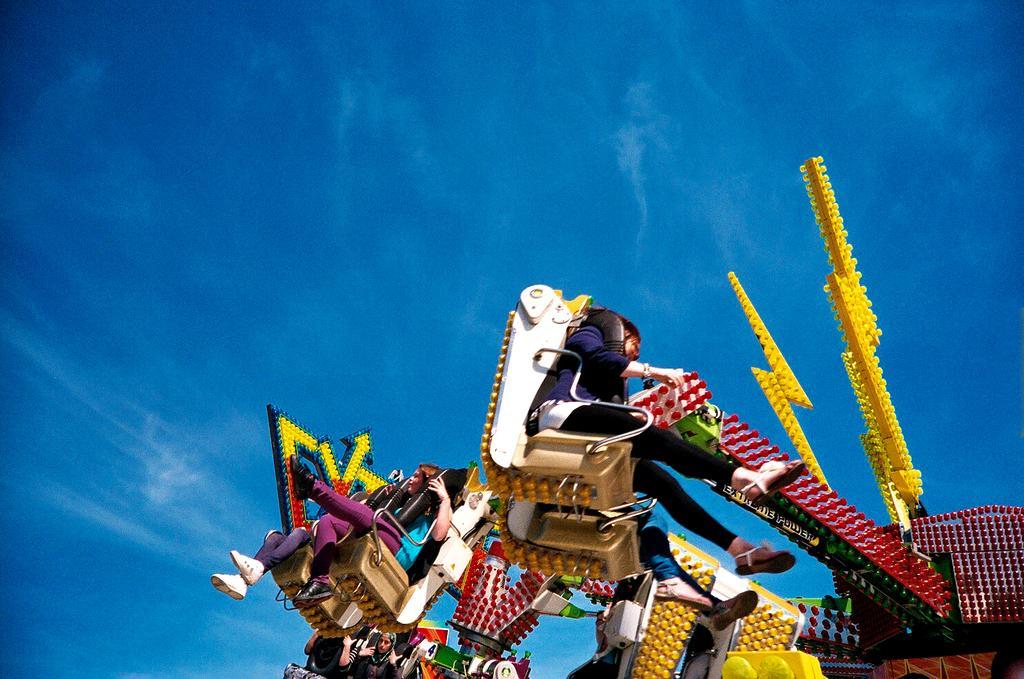In one or two sentences, can you explain what this image depicts? This is an outside view. Here I can see a few people are sitting in a vehicle. It seems to be an amusement ride. At the top, I can see the sky. 